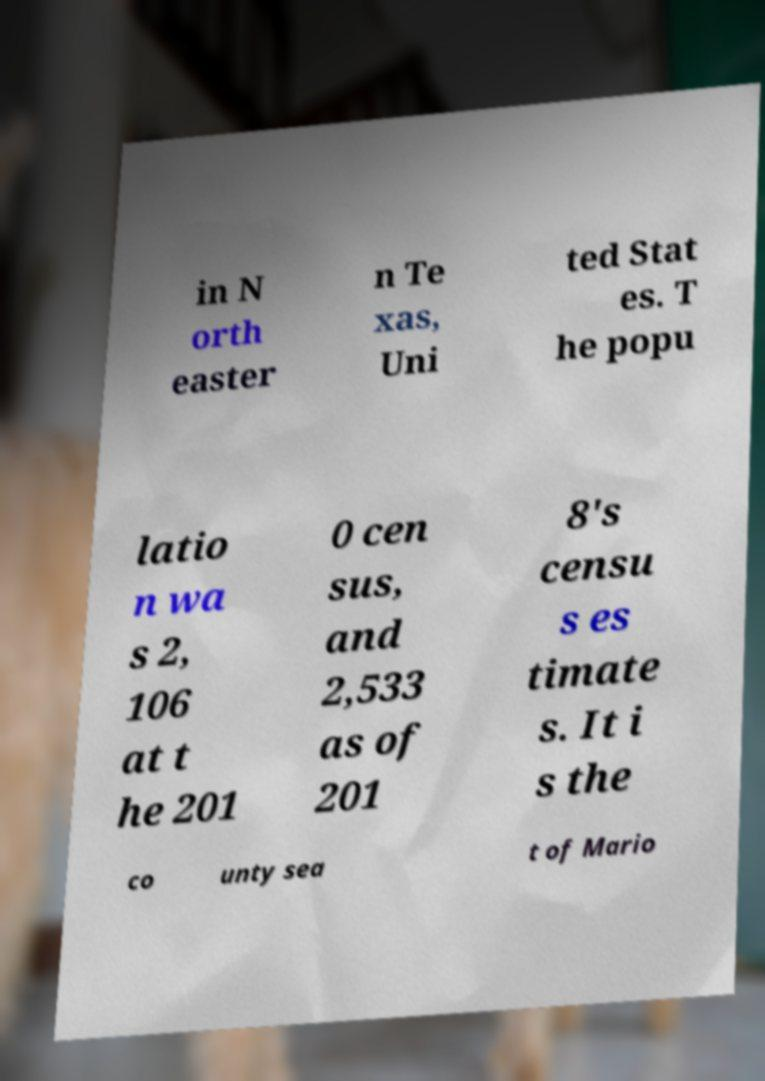There's text embedded in this image that I need extracted. Can you transcribe it verbatim? in N orth easter n Te xas, Uni ted Stat es. T he popu latio n wa s 2, 106 at t he 201 0 cen sus, and 2,533 as of 201 8's censu s es timate s. It i s the co unty sea t of Mario 